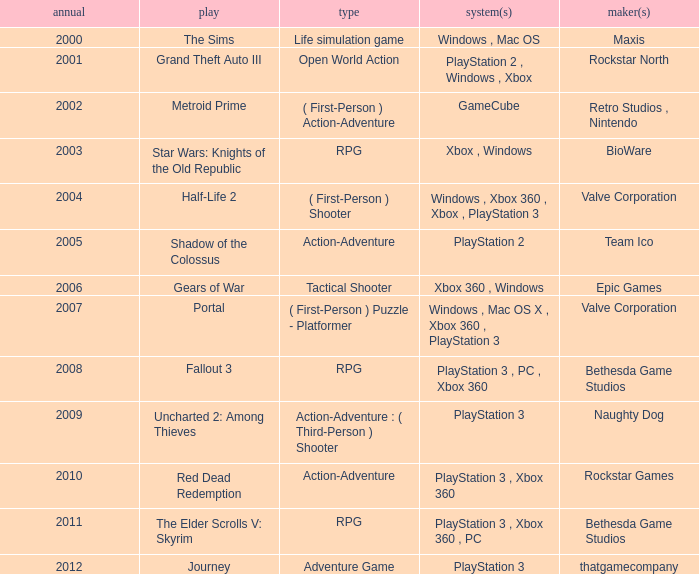Give me the full table as a dictionary. {'header': ['annual', 'play', 'type', 'system(s)', 'maker(s)'], 'rows': [['2000', 'The Sims', 'Life simulation game', 'Windows , Mac OS', 'Maxis'], ['2001', 'Grand Theft Auto III', 'Open World Action', 'PlayStation 2 , Windows , Xbox', 'Rockstar North'], ['2002', 'Metroid Prime', '( First-Person ) Action-Adventure', 'GameCube', 'Retro Studios , Nintendo'], ['2003', 'Star Wars: Knights of the Old Republic', 'RPG', 'Xbox , Windows', 'BioWare'], ['2004', 'Half-Life 2', '( First-Person ) Shooter', 'Windows , Xbox 360 , Xbox , PlayStation 3', 'Valve Corporation'], ['2005', 'Shadow of the Colossus', 'Action-Adventure', 'PlayStation 2', 'Team Ico'], ['2006', 'Gears of War', 'Tactical Shooter', 'Xbox 360 , Windows', 'Epic Games'], ['2007', 'Portal', '( First-Person ) Puzzle - Platformer', 'Windows , Mac OS X , Xbox 360 , PlayStation 3', 'Valve Corporation'], ['2008', 'Fallout 3', 'RPG', 'PlayStation 3 , PC , Xbox 360', 'Bethesda Game Studios'], ['2009', 'Uncharted 2: Among Thieves', 'Action-Adventure : ( Third-Person ) Shooter', 'PlayStation 3', 'Naughty Dog'], ['2010', 'Red Dead Redemption', 'Action-Adventure', 'PlayStation 3 , Xbox 360', 'Rockstar Games'], ['2011', 'The Elder Scrolls V: Skyrim', 'RPG', 'PlayStation 3 , Xbox 360 , PC', 'Bethesda Game Studios'], ['2012', 'Journey', 'Adventure Game', 'PlayStation 3', 'thatgamecompany']]} What's the genre of The Sims before 2002? Life simulation game. 